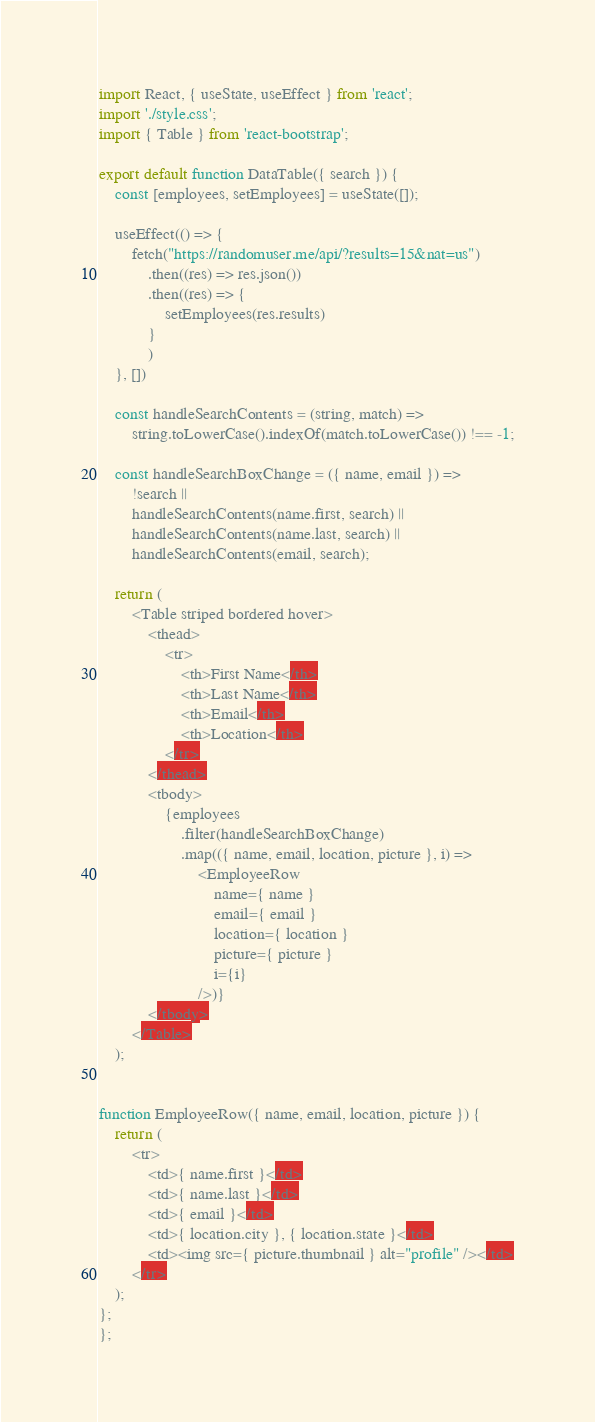Convert code to text. <code><loc_0><loc_0><loc_500><loc_500><_JavaScript_>import React, { useState, useEffect } from 'react';
import './style.css';
import { Table } from 'react-bootstrap';

export default function DataTable({ search }) {
    const [employees, setEmployees] = useState([]);

    useEffect(() => {
        fetch("https://randomuser.me/api/?results=15&nat=us")
            .then((res) => res.json())
            .then((res) => {
                setEmployees(res.results)
            }
            )
    }, [])

    const handleSearchContents = (string, match) =>
        string.toLowerCase().indexOf(match.toLowerCase()) !== -1;

    const handleSearchBoxChange = ({ name, email }) =>
        !search ||
        handleSearchContents(name.first, search) ||
        handleSearchContents(name.last, search) ||
        handleSearchContents(email, search);

    return (
        <Table striped bordered hover>
            <thead>
                <tr>
                    <th>First Name</th>
                    <th>Last Name</th>
                    <th>Email</th>
                    <th>Location</th>
                </tr>
            </thead>
            <tbody>
                {employees
                    .filter(handleSearchBoxChange)
                    .map(({ name, email, location, picture }, i) =>
                        <EmployeeRow
                            name={ name }
                            email={ email }
                            location={ location }
                            picture={ picture }
                            i={i}
                        />)}
            </tbody>
        </Table>
    );


function EmployeeRow({ name, email, location, picture }) {
    return (
        <tr>
            <td>{ name.first }</td>
            <td>{ name.last }</td>
            <td>{ email }</td>
            <td>{ location.city }, { location.state }</td>
            <td><img src={ picture.thumbnail } alt="profile" /></td>
        </tr>
    );
};
};

</code> 